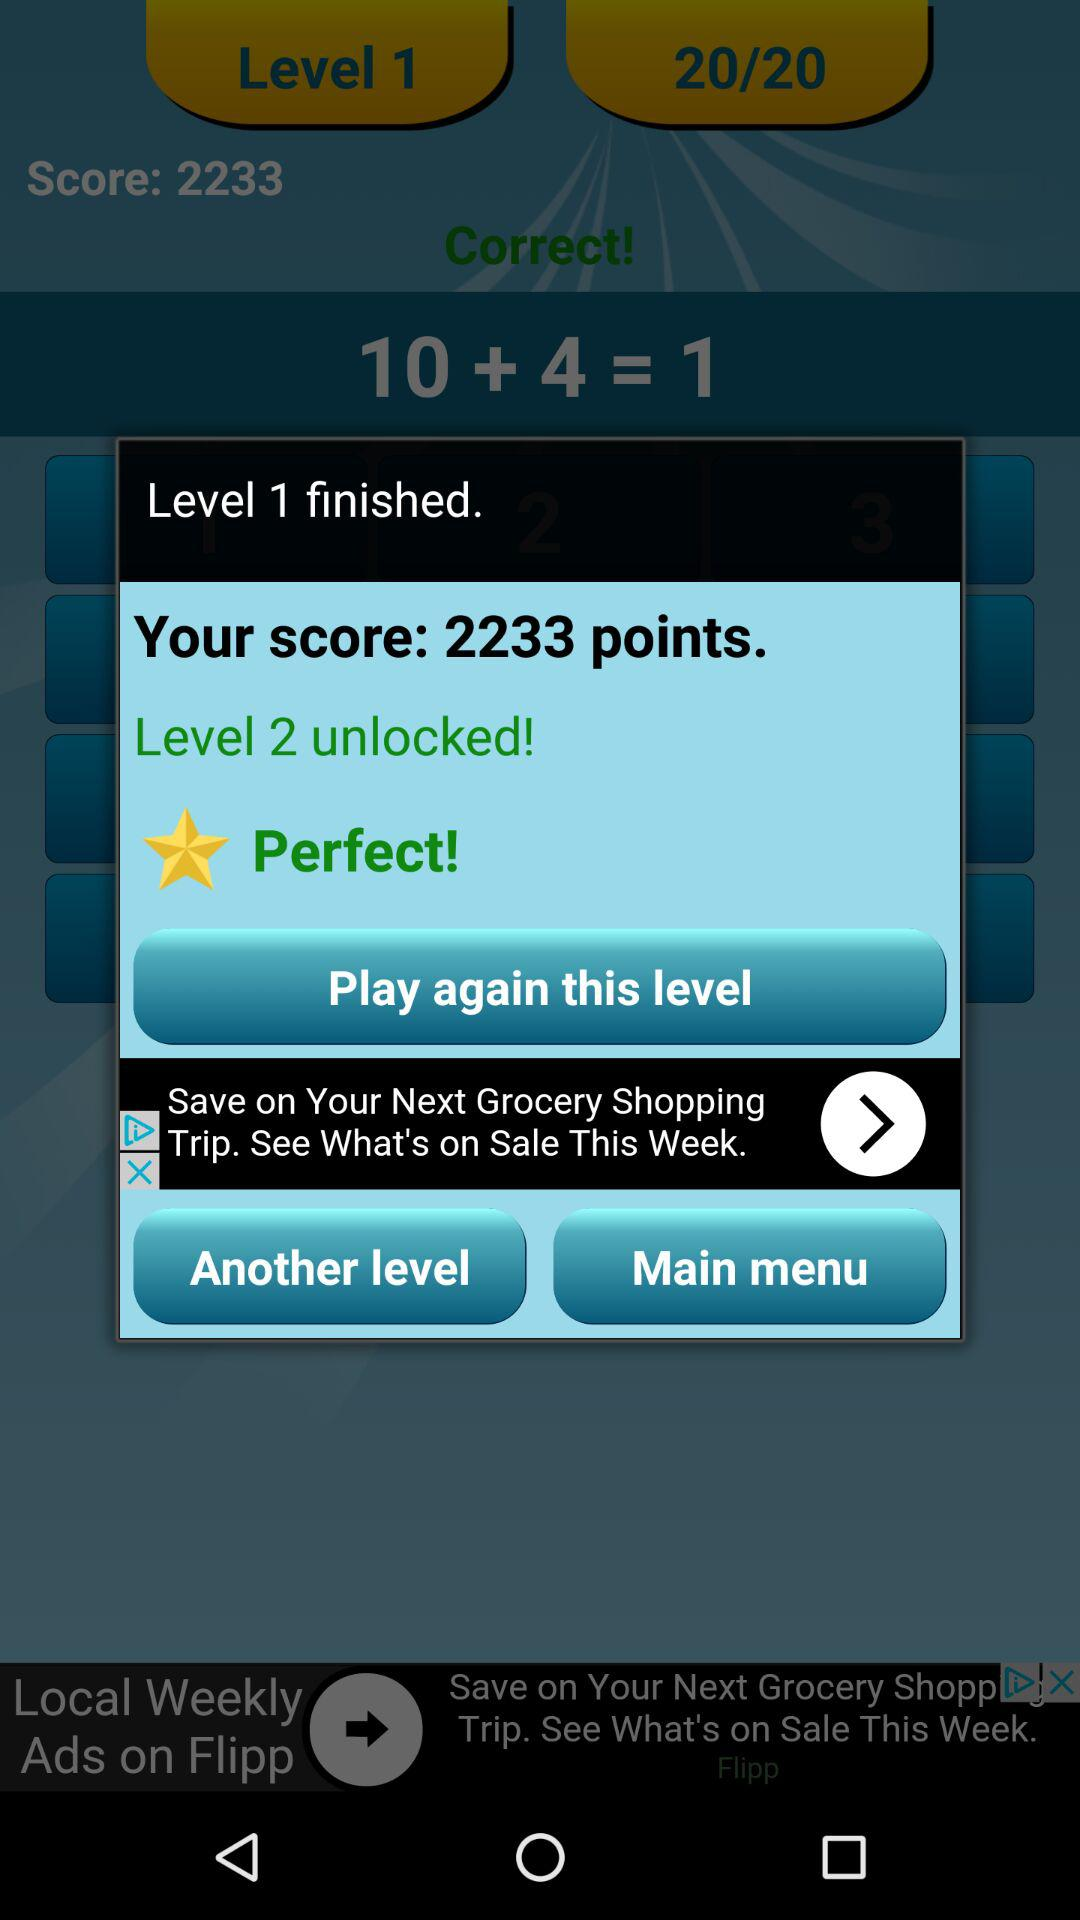What is the score? The score is 2233 points. 